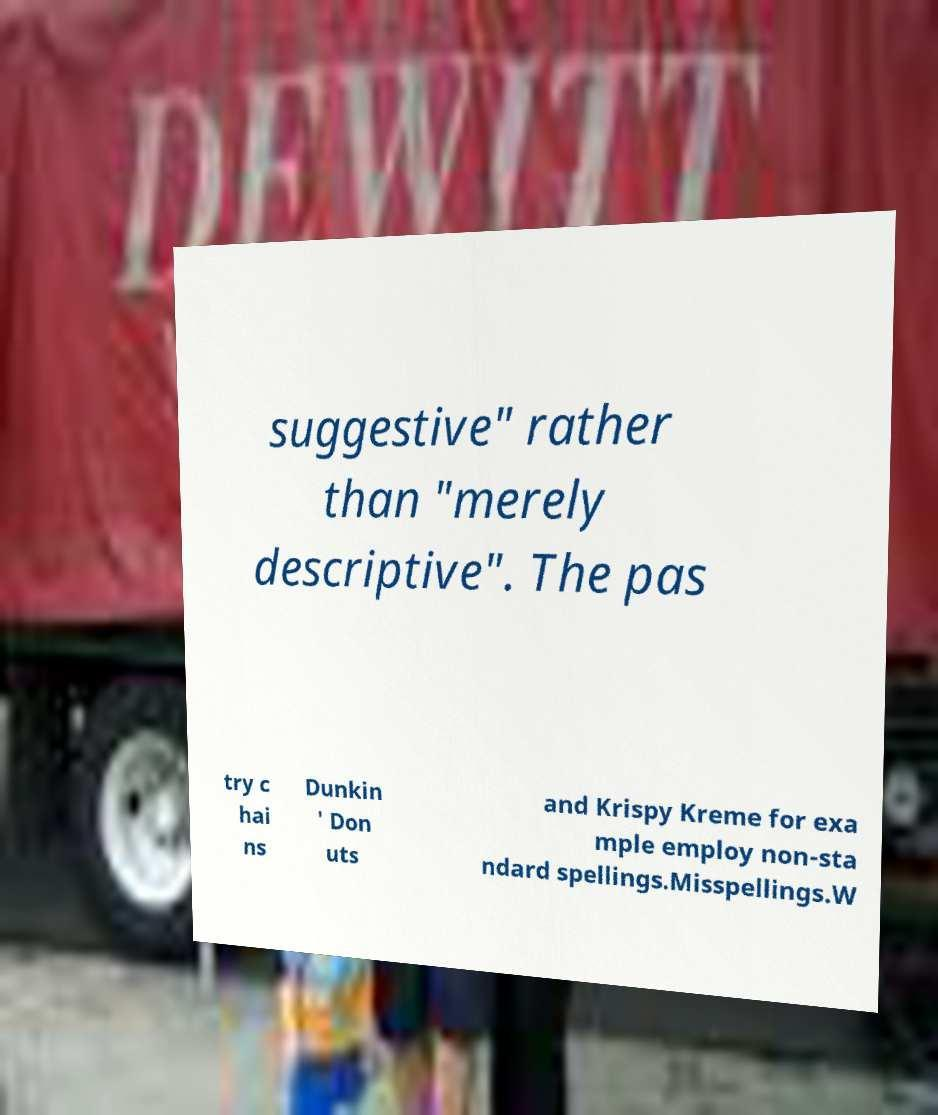Could you assist in decoding the text presented in this image and type it out clearly? suggestive" rather than "merely descriptive". The pas try c hai ns Dunkin ' Don uts and Krispy Kreme for exa mple employ non-sta ndard spellings.Misspellings.W 